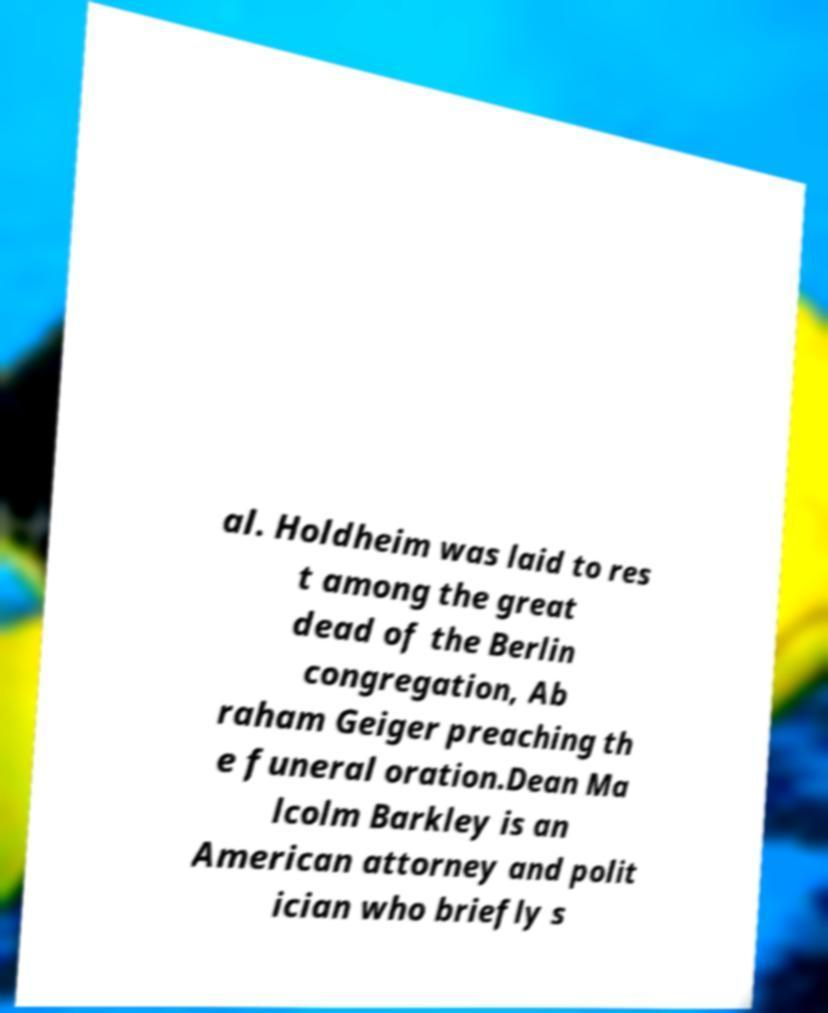What messages or text are displayed in this image? I need them in a readable, typed format. al. Holdheim was laid to res t among the great dead of the Berlin congregation, Ab raham Geiger preaching th e funeral oration.Dean Ma lcolm Barkley is an American attorney and polit ician who briefly s 